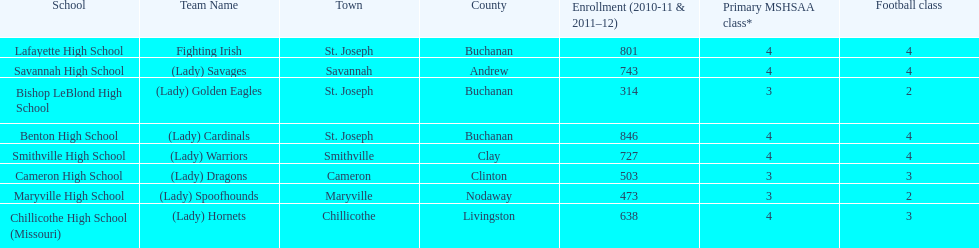What are the three schools in the town of st. joseph? St. Joseph, St. Joseph, St. Joseph. Of the three schools in st. joseph which school's team name does not depict a type of animal? Lafayette High School. 